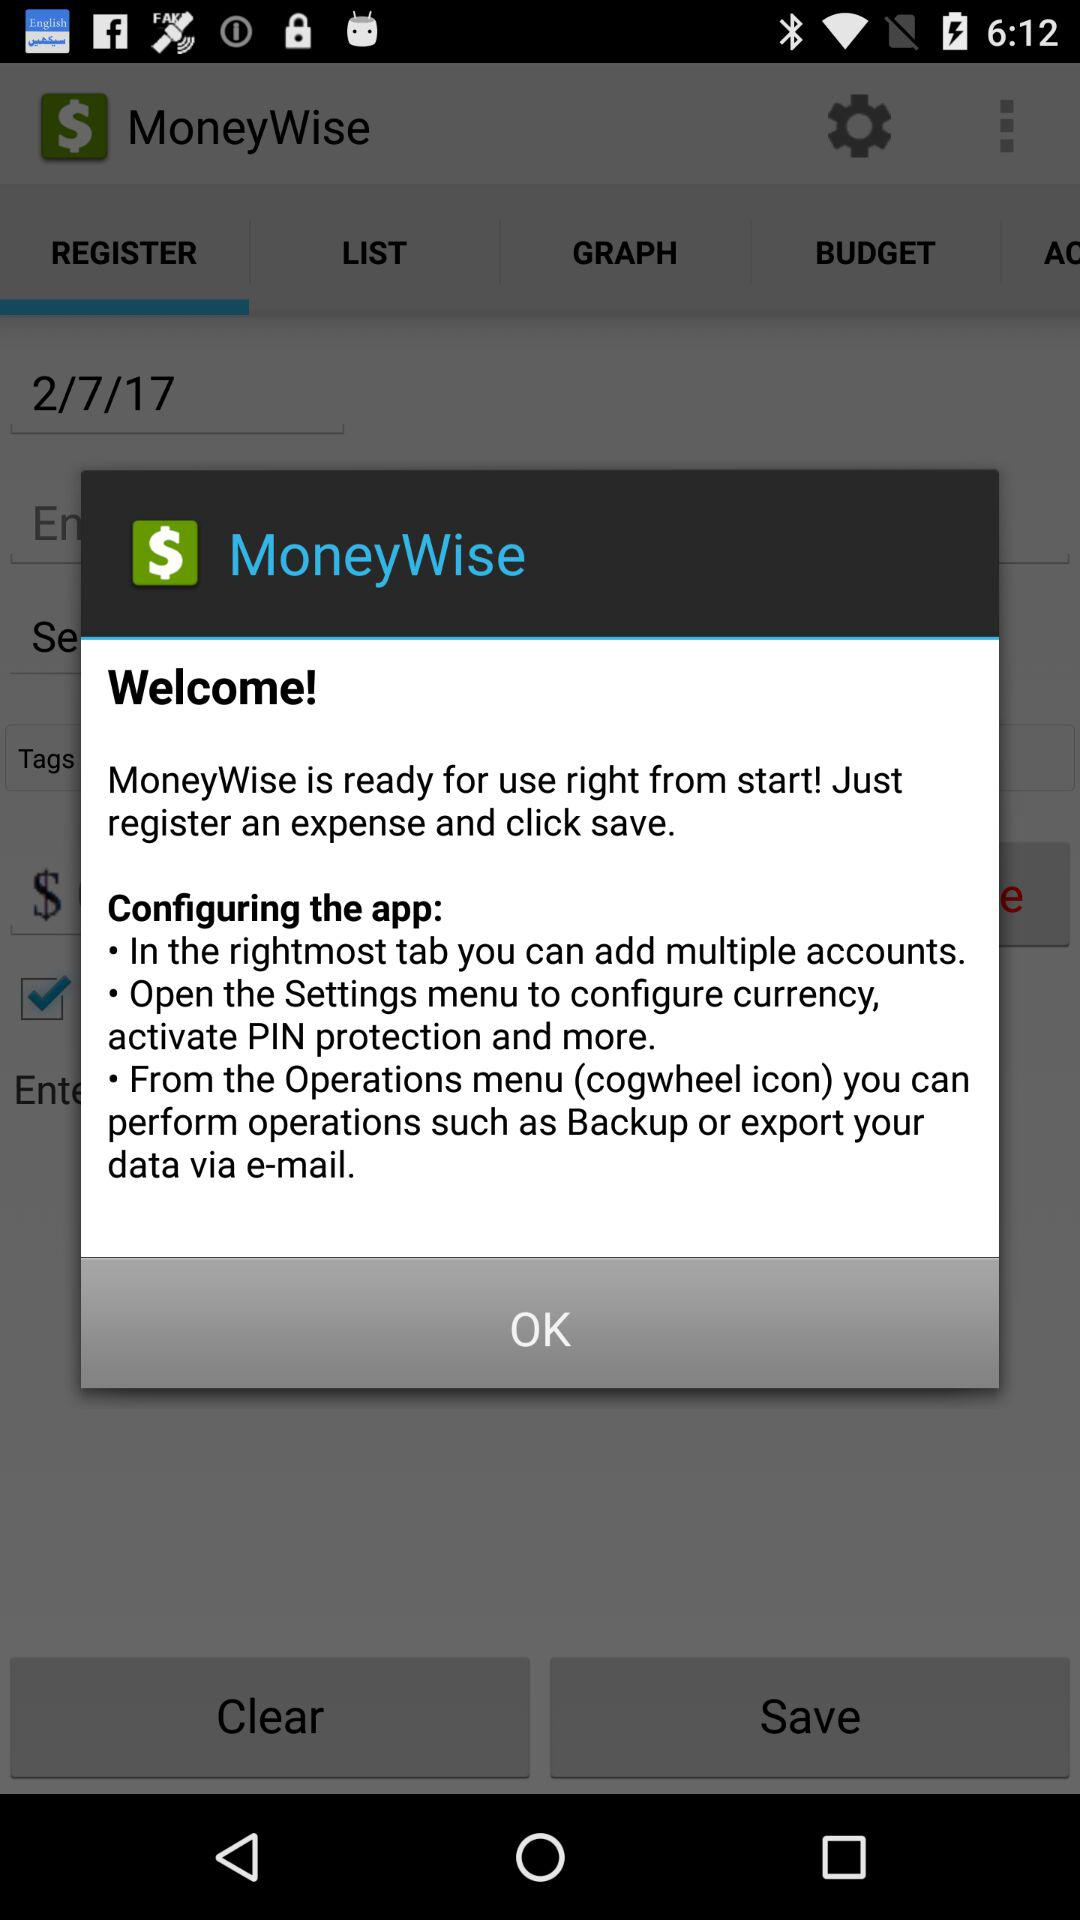How many operations can be performed from the Operations menu?
Answer the question using a single word or phrase. 2 